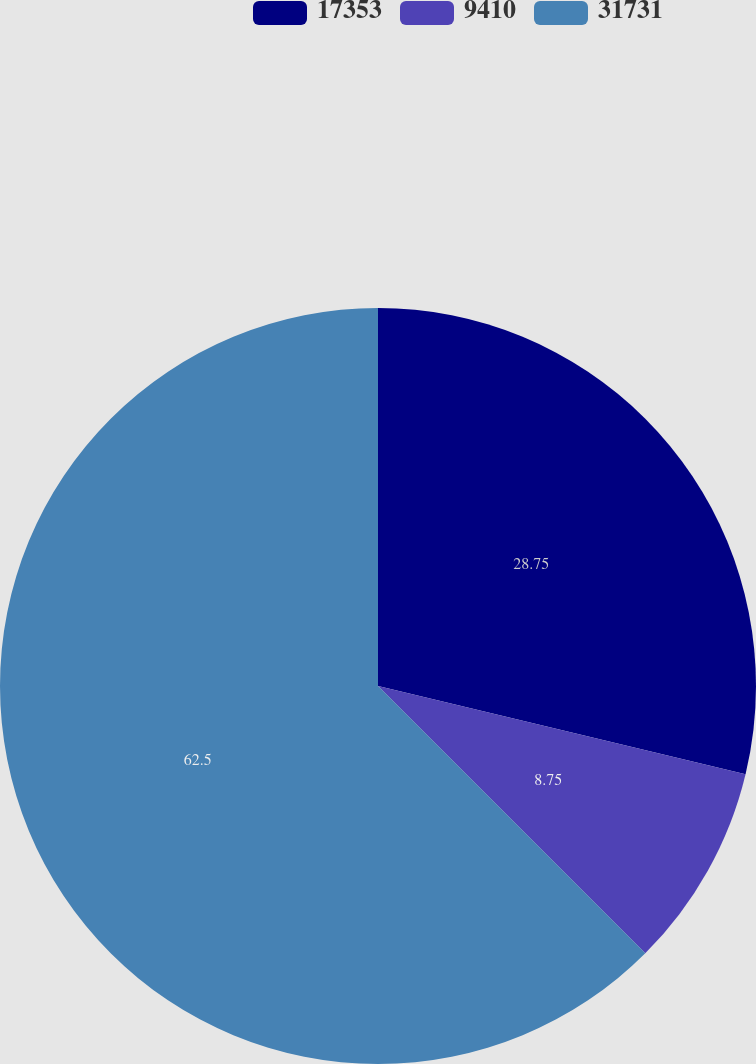Convert chart to OTSL. <chart><loc_0><loc_0><loc_500><loc_500><pie_chart><fcel>17353<fcel>9410<fcel>31731<nl><fcel>28.75%<fcel>8.75%<fcel>62.5%<nl></chart> 